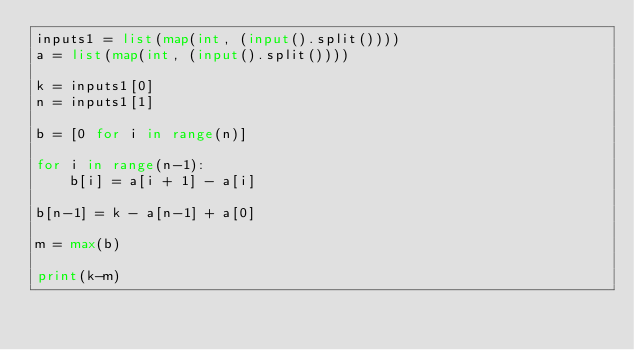<code> <loc_0><loc_0><loc_500><loc_500><_Python_>inputs1 = list(map(int, (input().split())))
a = list(map(int, (input().split())))

k = inputs1[0]
n = inputs1[1]

b = [0 for i in range(n)]

for i in range(n-1):
    b[i] = a[i + 1] - a[i]

b[n-1] = k - a[n-1] + a[0]

m = max(b)

print(k-m)
</code> 